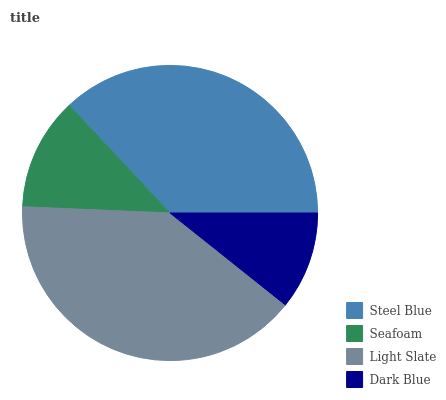Is Dark Blue the minimum?
Answer yes or no. Yes. Is Light Slate the maximum?
Answer yes or no. Yes. Is Seafoam the minimum?
Answer yes or no. No. Is Seafoam the maximum?
Answer yes or no. No. Is Steel Blue greater than Seafoam?
Answer yes or no. Yes. Is Seafoam less than Steel Blue?
Answer yes or no. Yes. Is Seafoam greater than Steel Blue?
Answer yes or no. No. Is Steel Blue less than Seafoam?
Answer yes or no. No. Is Steel Blue the high median?
Answer yes or no. Yes. Is Seafoam the low median?
Answer yes or no. Yes. Is Seafoam the high median?
Answer yes or no. No. Is Dark Blue the low median?
Answer yes or no. No. 